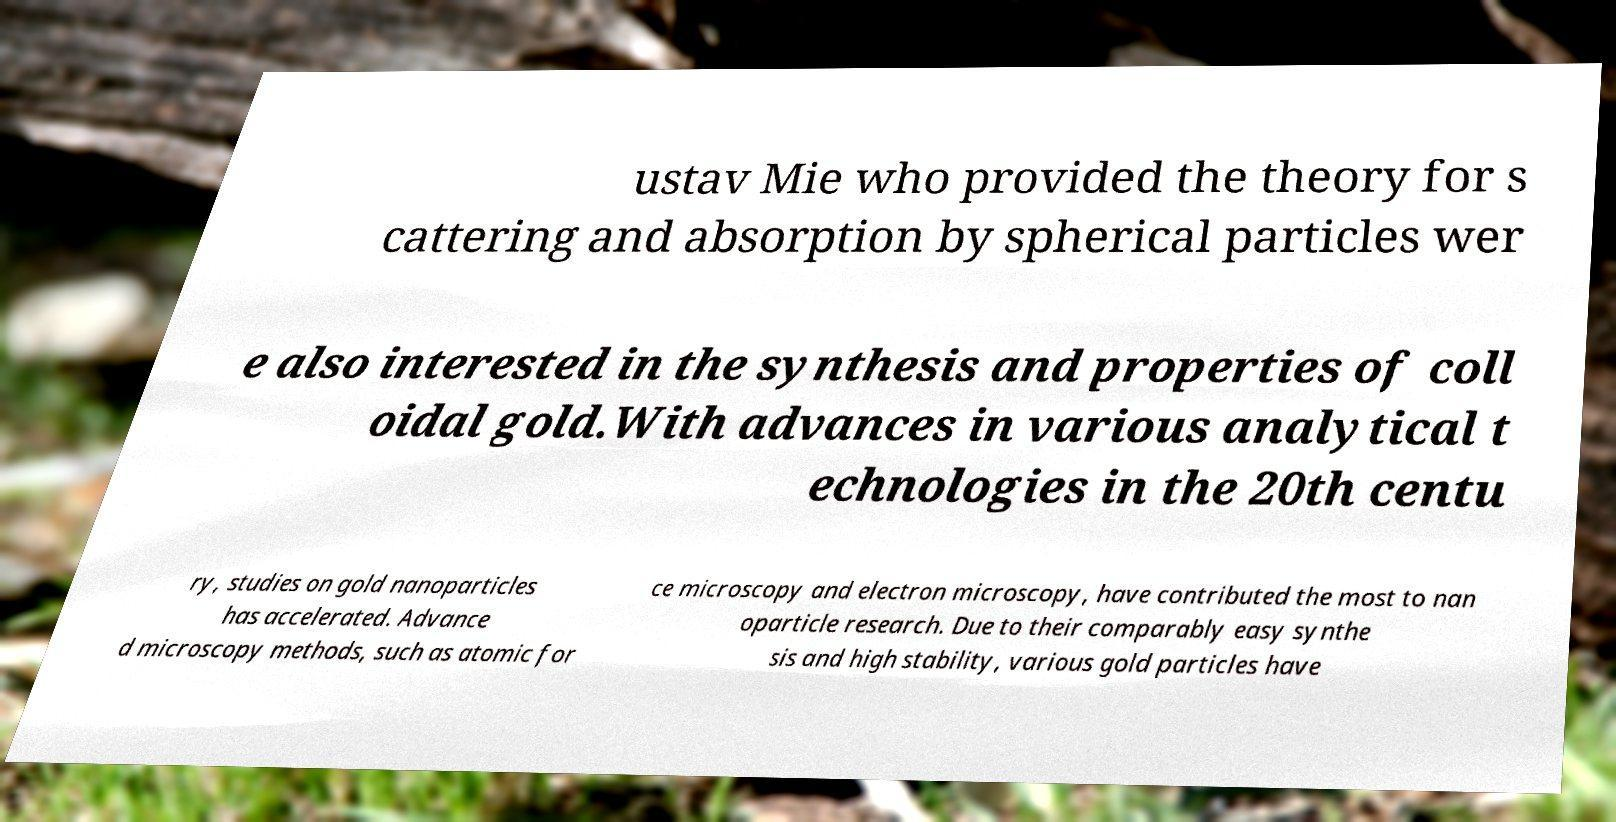What messages or text are displayed in this image? I need them in a readable, typed format. ustav Mie who provided the theory for s cattering and absorption by spherical particles wer e also interested in the synthesis and properties of coll oidal gold.With advances in various analytical t echnologies in the 20th centu ry, studies on gold nanoparticles has accelerated. Advance d microscopy methods, such as atomic for ce microscopy and electron microscopy, have contributed the most to nan oparticle research. Due to their comparably easy synthe sis and high stability, various gold particles have 